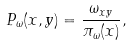Convert formula to latex. <formula><loc_0><loc_0><loc_500><loc_500>P _ { \omega } ( x , y ) = \frac { \omega _ { x y } } { \pi _ { \omega } ( x ) } ,</formula> 